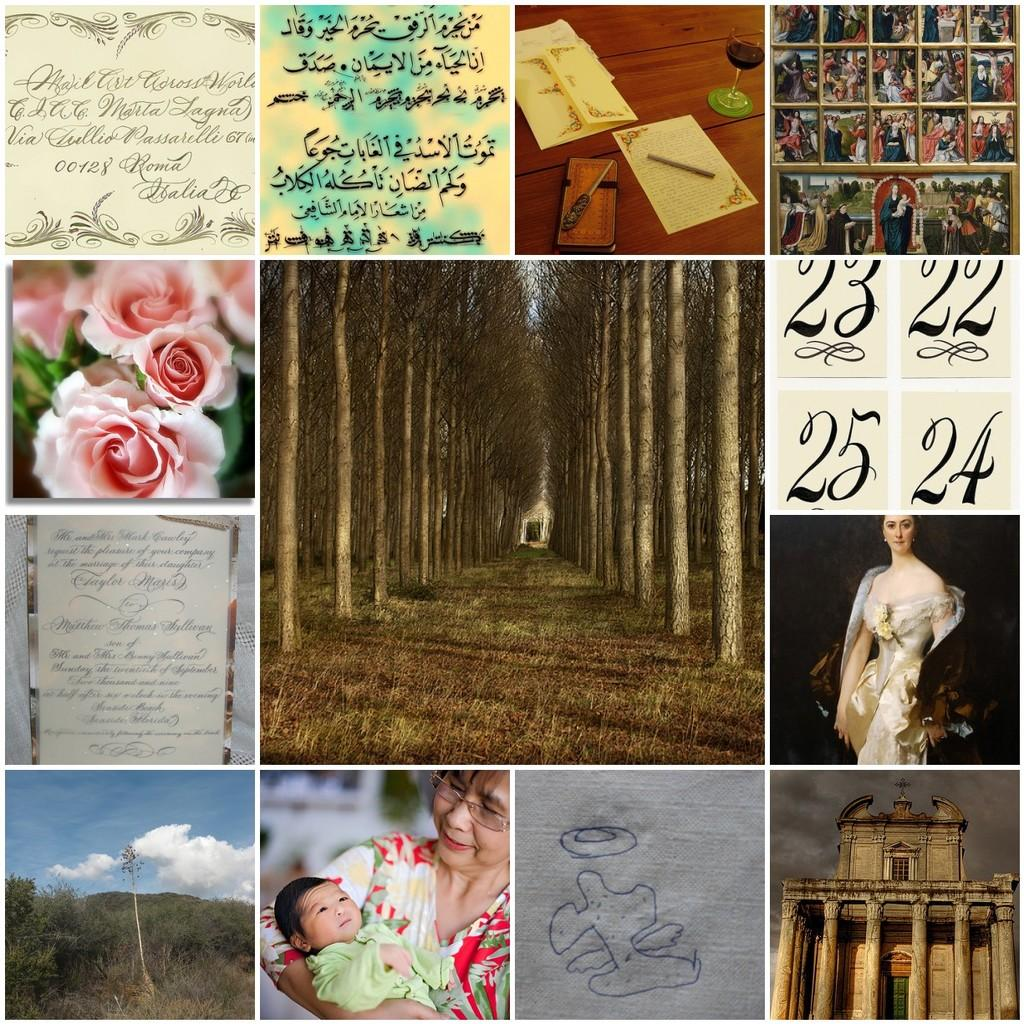What type of artwork is the image? The image is a collage. What natural elements can be seen in the image? There are trees and clouds in the image. What man-made structures are present in the image? There is a building in the image. What part of the natural environment is visible in the image? The sky is visible in the image. What type of flora is present in the image? There are flowers in the image. What stationary items are visible in the image? There are papers, glasses, and pens in the image. Who is present in the image? There is a woman in the image. What type of copper material is used to build the boat in the image? There is no boat present in the image, and therefore no copper material can be identified. What type of club is the woman holding in the image? There is no club present in the image; the woman is not holding any object. 